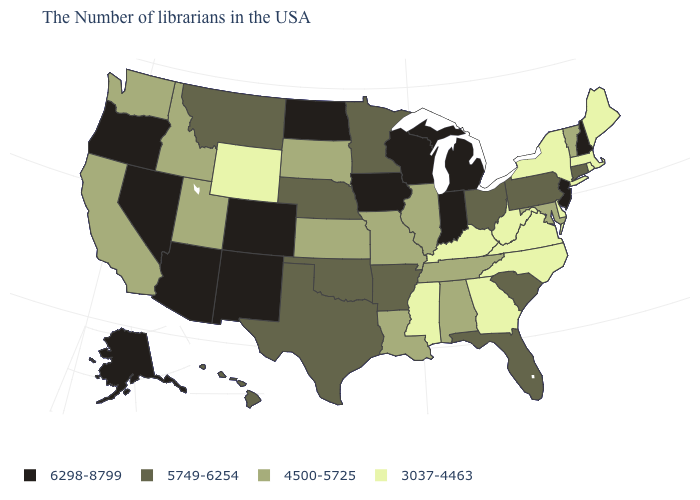Among the states that border Utah , which have the lowest value?
Give a very brief answer. Wyoming. What is the value of Michigan?
Answer briefly. 6298-8799. Does the map have missing data?
Concise answer only. No. What is the value of Maine?
Concise answer only. 3037-4463. What is the lowest value in the USA?
Be succinct. 3037-4463. What is the value of Georgia?
Write a very short answer. 3037-4463. What is the value of Washington?
Quick response, please. 4500-5725. Among the states that border Indiana , which have the highest value?
Short answer required. Michigan. How many symbols are there in the legend?
Be succinct. 4. Does New Jersey have the highest value in the Northeast?
Short answer required. Yes. What is the value of Michigan?
Concise answer only. 6298-8799. Does the first symbol in the legend represent the smallest category?
Write a very short answer. No. Name the states that have a value in the range 5749-6254?
Answer briefly. Connecticut, Pennsylvania, South Carolina, Ohio, Florida, Arkansas, Minnesota, Nebraska, Oklahoma, Texas, Montana, Hawaii. Name the states that have a value in the range 3037-4463?
Answer briefly. Maine, Massachusetts, Rhode Island, New York, Delaware, Virginia, North Carolina, West Virginia, Georgia, Kentucky, Mississippi, Wyoming. What is the value of Louisiana?
Concise answer only. 4500-5725. 